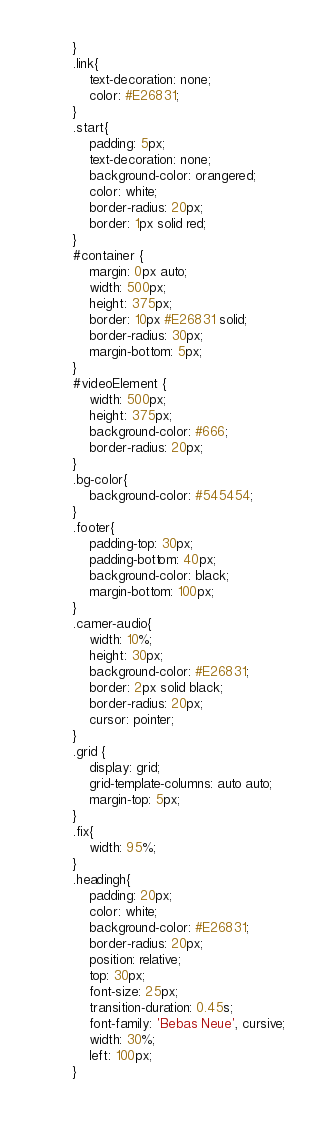<code> <loc_0><loc_0><loc_500><loc_500><_CSS_>}
.link{
    text-decoration: none;
    color: #E26831;
}
.start{
    padding: 5px;
    text-decoration: none;
    background-color: orangered;
    color: white;
    border-radius: 20px;
    border: 1px solid red;
}
#container {
	margin: 0px auto;
	width: 500px;
	height: 375px;
	border: 10px #E26831 solid;
    border-radius: 30px;
    margin-bottom: 5px;
}
#videoElement {
	width: 500px;
	height: 375px;
	background-color: #666;
    border-radius: 20px;
}
.bg-color{
    background-color: #545454;
}
.footer{
    padding-top: 30px;
    padding-bottom: 40px;
    background-color: black;
    margin-bottom: 100px;
}
.camer-audio{
    width: 10%;
    height: 30px;
    background-color: #E26831;
    border: 2px solid black;
    border-radius: 20px;
    cursor: pointer;
}
.grid { 
    display: grid; 
    grid-template-columns: auto auto; 
    margin-top: 5px;
}
.fix{
    width: 95%;
}
.headingh{
    padding: 20px;
    color: white;
    background-color: #E26831;
    border-radius: 20px;
    position: relative;
    top: 30px;
    font-size: 25px;
    transition-duration: 0.45s;
    font-family: 'Bebas Neue', cursive;
    width: 30%;
    left: 100px;
}</code> 